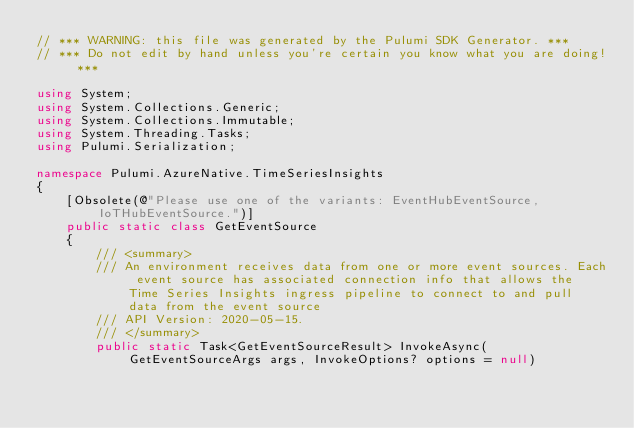Convert code to text. <code><loc_0><loc_0><loc_500><loc_500><_C#_>// *** WARNING: this file was generated by the Pulumi SDK Generator. ***
// *** Do not edit by hand unless you're certain you know what you are doing! ***

using System;
using System.Collections.Generic;
using System.Collections.Immutable;
using System.Threading.Tasks;
using Pulumi.Serialization;

namespace Pulumi.AzureNative.TimeSeriesInsights
{
    [Obsolete(@"Please use one of the variants: EventHubEventSource, IoTHubEventSource.")]
    public static class GetEventSource
    {
        /// <summary>
        /// An environment receives data from one or more event sources. Each event source has associated connection info that allows the Time Series Insights ingress pipeline to connect to and pull data from the event source
        /// API Version: 2020-05-15.
        /// </summary>
        public static Task<GetEventSourceResult> InvokeAsync(GetEventSourceArgs args, InvokeOptions? options = null)</code> 